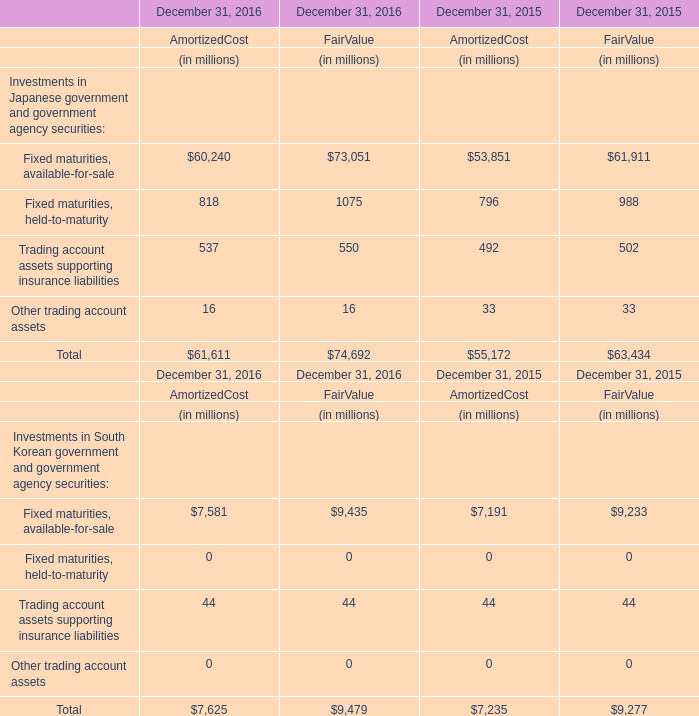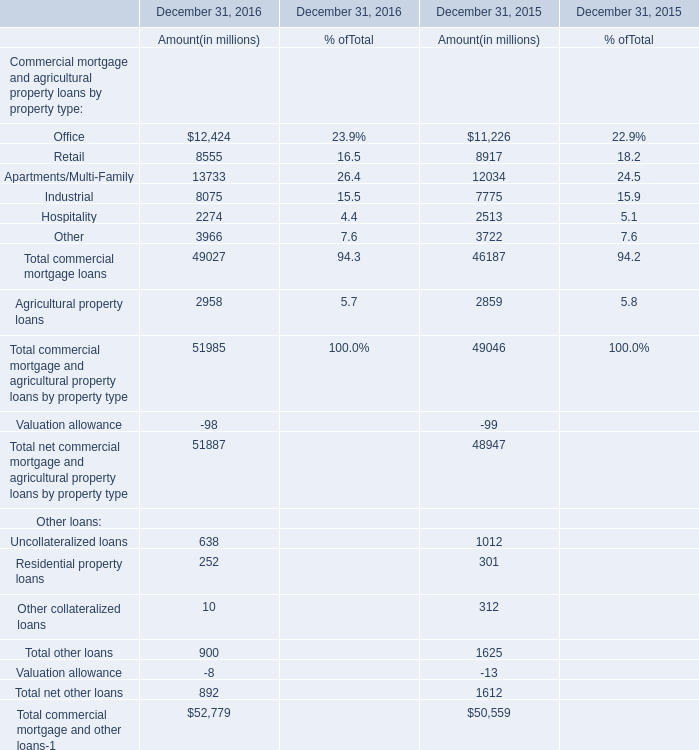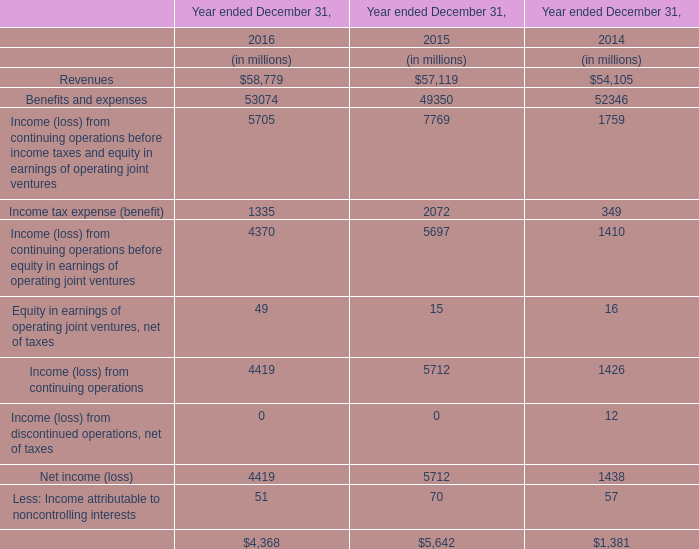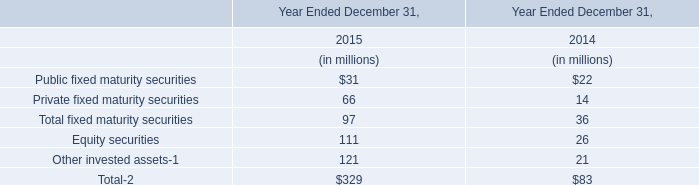How many element continues to increase every year from 2015 to 2016 for AmortizedCost ? 
Answer: 6. 